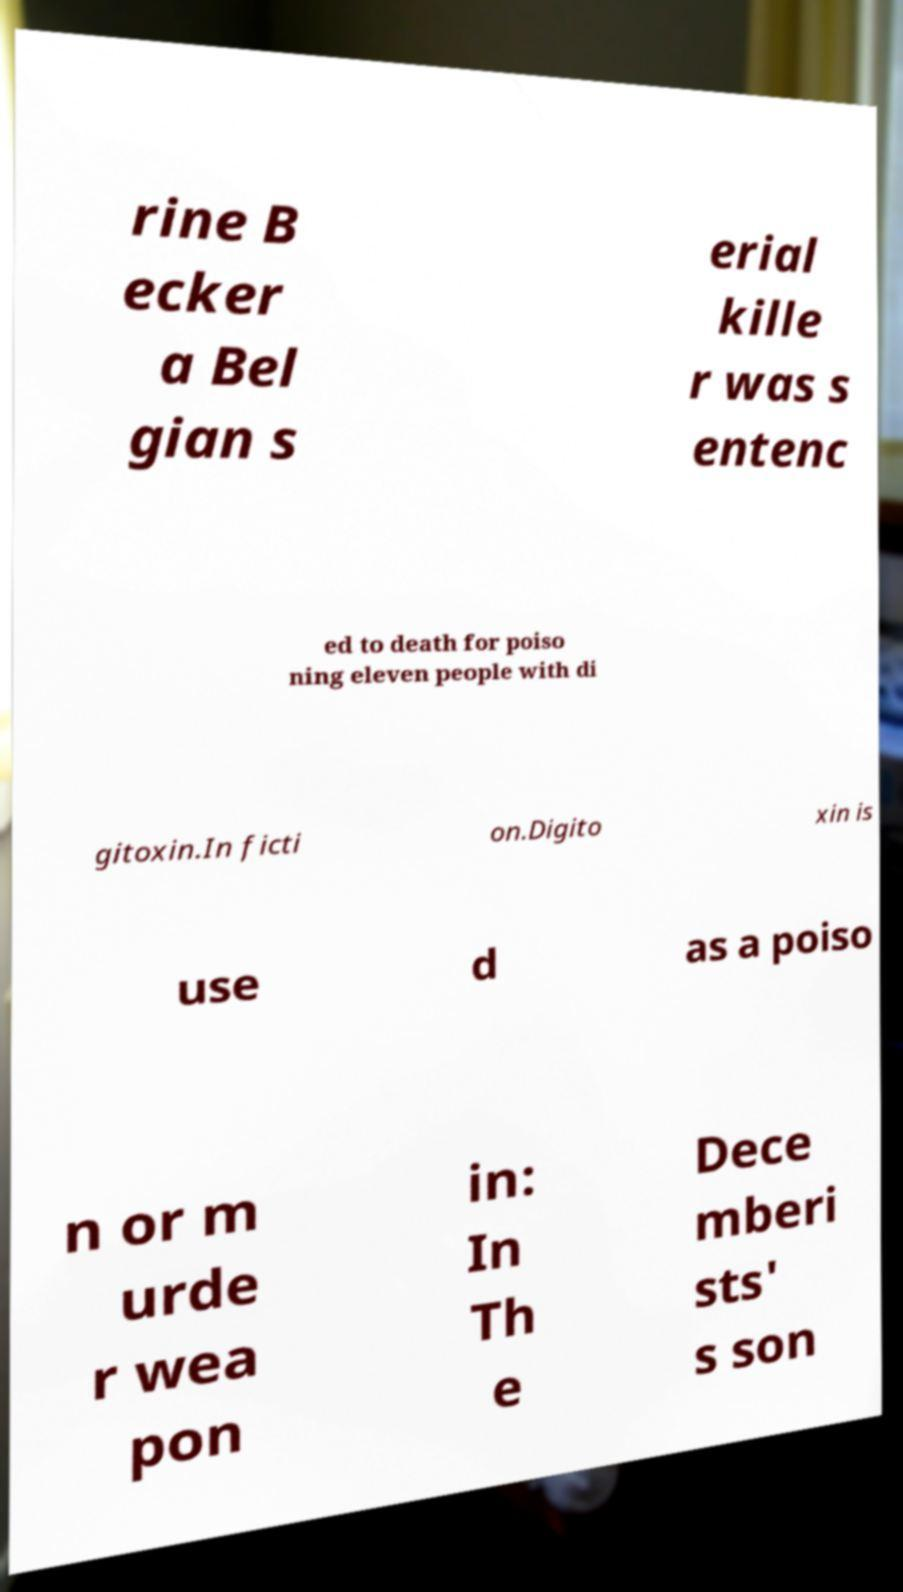For documentation purposes, I need the text within this image transcribed. Could you provide that? rine B ecker a Bel gian s erial kille r was s entenc ed to death for poiso ning eleven people with di gitoxin.In ficti on.Digito xin is use d as a poiso n or m urde r wea pon in: In Th e Dece mberi sts' s son 